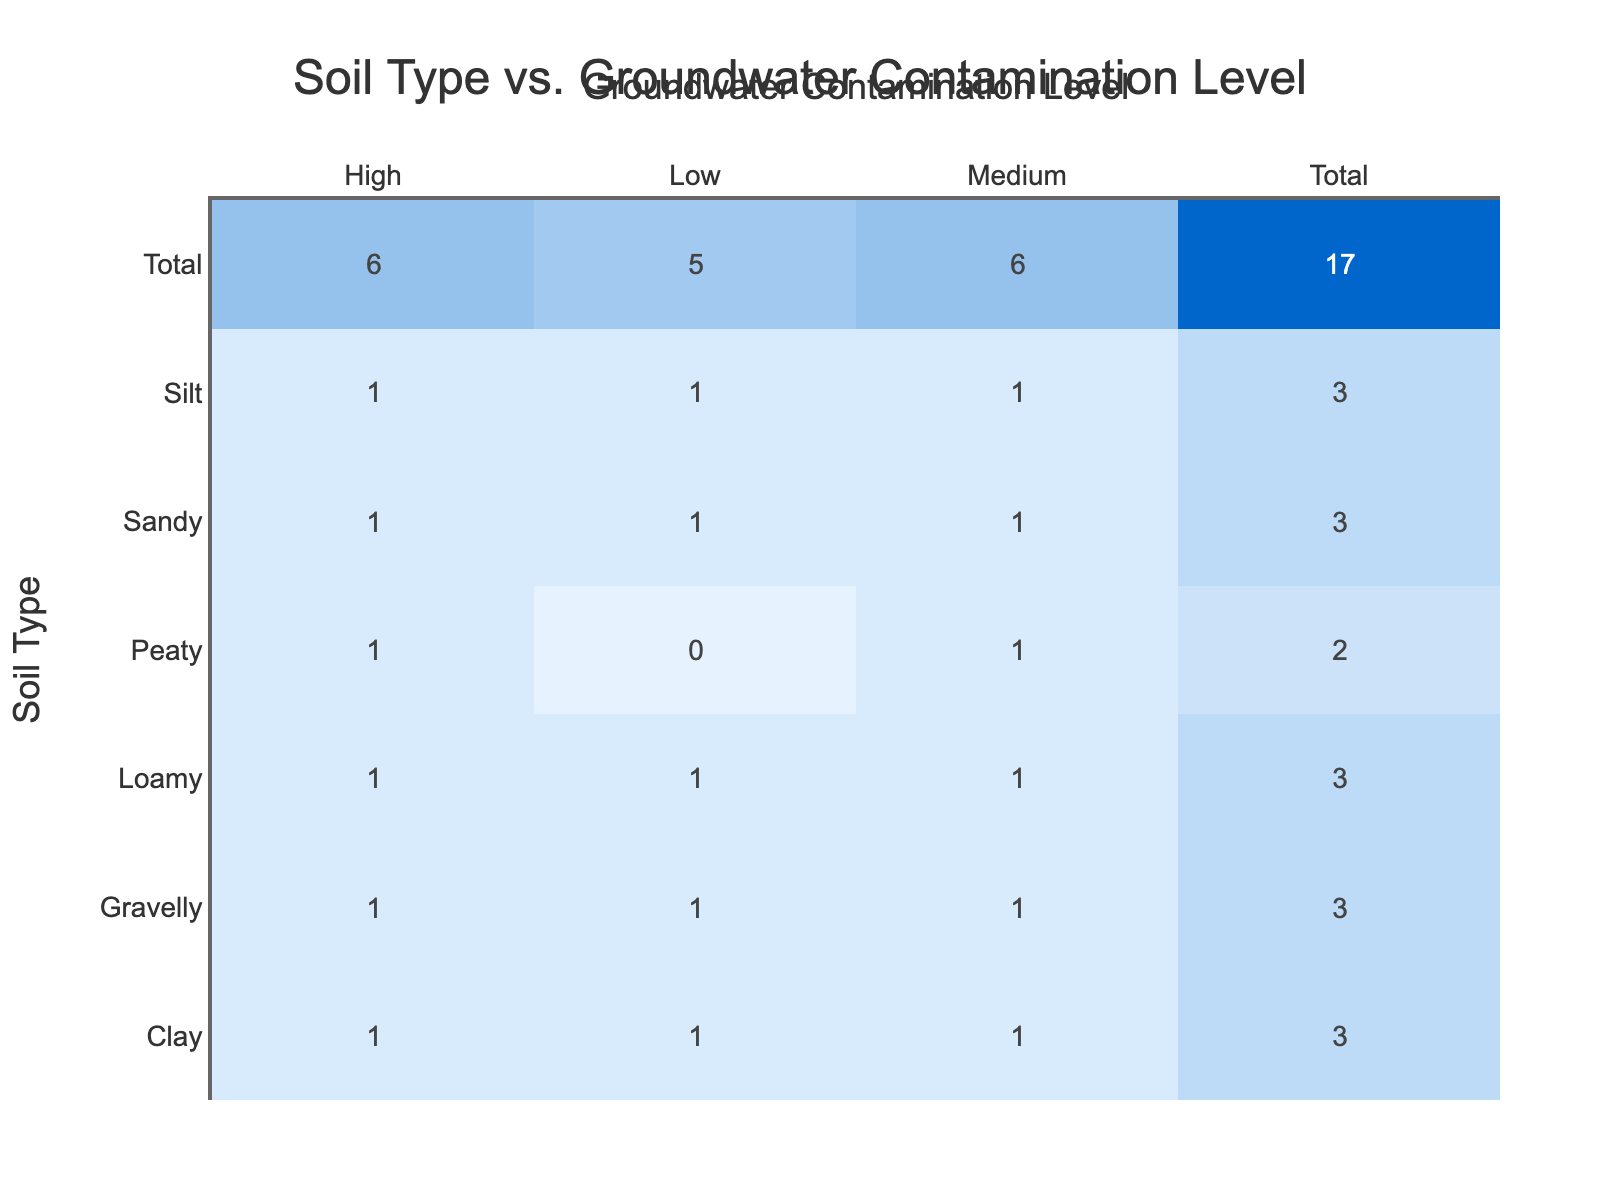What is the number of soil types that show high groundwater contamination? From the contingency table, we can see that there are three soil types (Clay, Sandy, and Loamy) that have "High" contamination levels mentioned. The total count for "High" for each type is three. Therefore, the number of soil types with high groundwater contamination is 3.
Answer: 3 Which soil type has the highest level of groundwater contamination? Looking at the "High" contamination level, the soil types listed are Clay, Sandy, and Loamy, each having one entry. Since they all have the same count of 1, no soil type stands out distinctly. However, by assessing the levels, they all categorize at a high level. But Clay, Sandy, and Loamy share the same count.
Answer: Clay, Sandy, and Loamy What is the total number of soil compositions that lead to low groundwater contamination? In the contingency table, the "Low" contamination level has counts for five soil types: Clay, Sandy, Loamy, Silt, and Gravelly. Each soil type has 1 entry for low contamination, making the total count of soil types leading to low groundwater contamination 5.
Answer: 5 Is it true that Peaty soil has low levels of groundwater contamination? Referring to the table, It is noted that Peaty soil only has entries for Medium and High contamination levels. Therefore, it does not have low levels of contamination present. Hence, the statement is false.
Answer: No What is the average number of soil types that report medium contamination levels? The table shows Clay, Sandy, Loamy, and Peaty all report medium contamination levels, accounting to a total of 4 soil types. To find the average, we take the total entries reporting medium, which is 4, and since they are all distinct, dividing by the count of soil types (4) results in an average of 1.
Answer: 1 How many total entries are there for Gravelly soil? The table shows Gravelly soil has three contamination levels: one for Low, one for Medium, and one for High. Thus, the total number of entries specifically for Gravelly soil is 3.
Answer: 3 Is it true that no soil type has a medium contamination level? By analyzing the contamination data, several soil types (Clay, Sandy, Loamy, and Peaty) have a Medium contamination level, so the statement that no soil type has a medium contamination level is false.
Answer: No How many entries show a total of high and medium contamination levels for Silt? The entries indicate that Silt soil has one entry for Medium and one entry for High. Adding these two gives us a total of 2 entries showing either medium or high contamination levels for Silt.
Answer: 2 